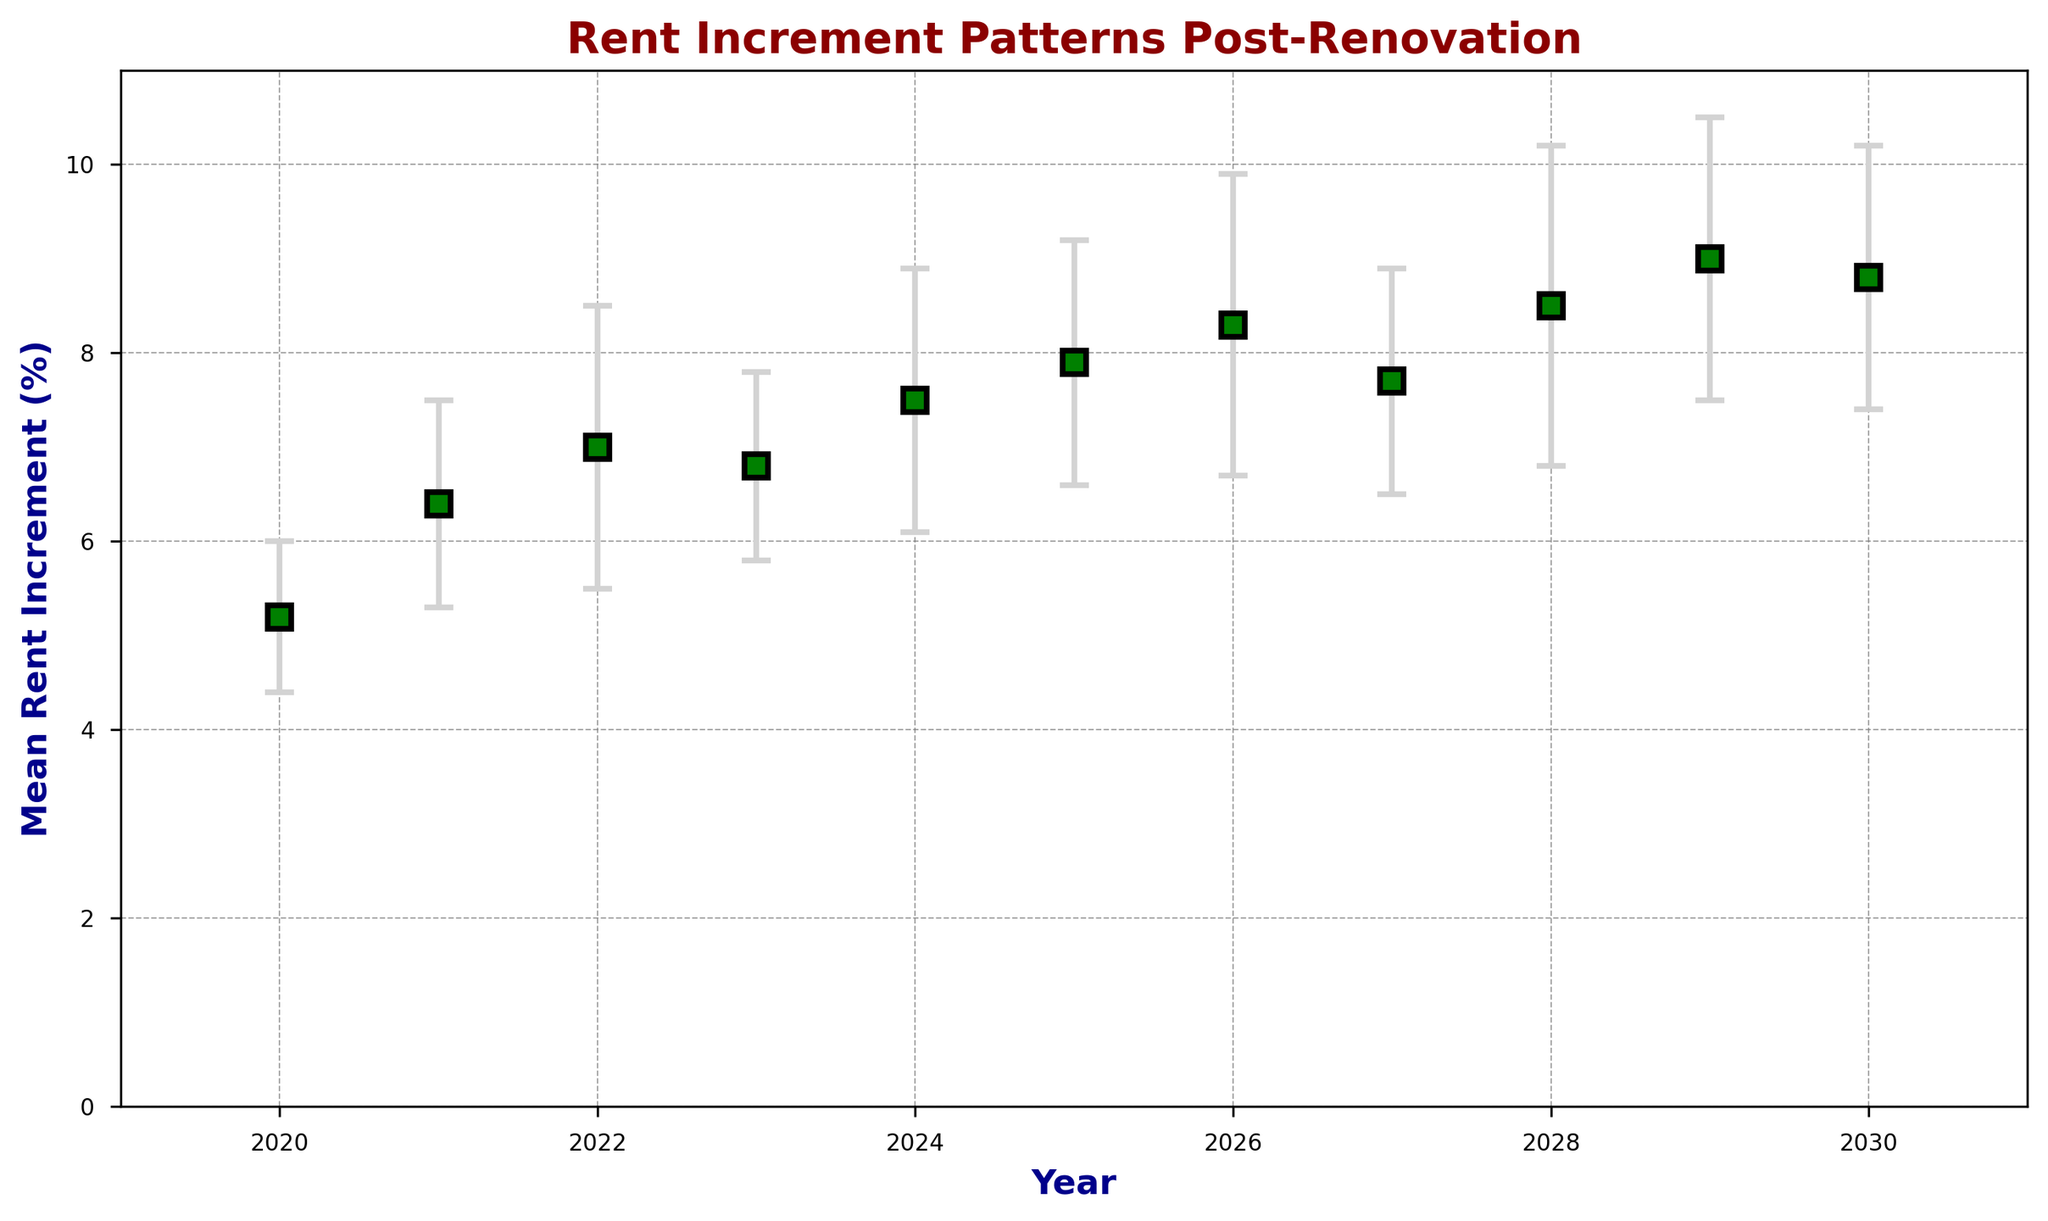What's the year with the highest mean rent increment? Look for the highest point on the mean rent increment line in the figure. 2029 has the highest mean value of 9.0%.
Answer: 2029 How much did the mean rent increment change from 2022 to 2023? Subtract the mean rent increment of 2022 from 2023: 6.8% - 7.0% = -0.2%.
Answer: -0.2% During which year is the discrepancy (standard deviation) the largest? Look for the longest error bar, which corresponds to the highest standard deviation. In 2028, the error bar is longest with a standard deviation of 1.7.
Answer: 2028 What is the average mean rent increment from 2025 to 2027? Add the mean rent increments for 2025, 2026, and 2027, then divide by 3. (7.9% + 8.3% + 7.7%) / 3 = 7.97%.
Answer: 7.97% In which year did the mean rent increment drop compared to the previous year? Compare sequential years and find when the next year's value is less. Between 2026 and 2027, it drops from 8.3% to 7.7%.
Answer: 2027 Which years have a mean rent increment greater than 8%? Check the years where the mean rent increment values are above 8. Years 2026, 2028, 2029, and 2030 fit this condition.
Answer: 2026, 2028, 2029, 2030 What is the total increment (sum) of mean rent from 2020 to 2022? Add the mean rent increments for 2020, 2021, and 2022. 5.2% + 6.4% + 7.0% = 18.6%.
Answer: 18.6% How does the mean rent increment in the year 2030 compare to the year 2029? Compare the mean increment values of 2030 and 2029. The mean rent increment in 2030 (8.8%) is slightly less than in 2029 (9.0%).
Answer: It's less What is the percentage increase in mean rent increment from 2020 to 2030? Calculate the difference, then divide by the 2020 value, and multiply by 100: [(8.8% - 5.2%) / 5.2%] * 100 = 69.23%.
Answer: 69.23% What is the range of the mean rent increment values displayed? Find the minimum and maximum mean rent increment values and subtract the minimum from the maximum. 9.0% (max in 2029) - 5.2% (min in 2020) = 3.8%.
Answer: 3.8% 